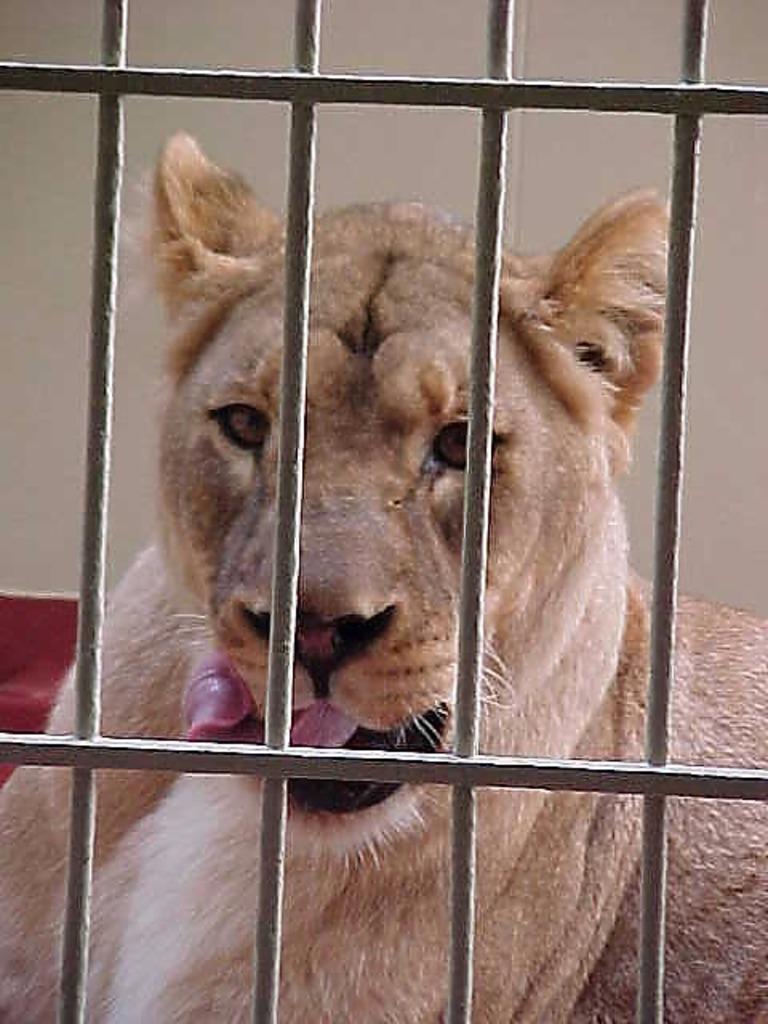Could you give a brief overview of what you see in this image? In this image, we can see grill. Through the grill, we can see an animal. Background we can see the wall. 